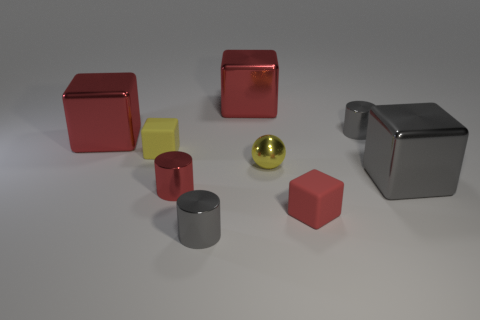Subtract all red cubes. How many were subtracted if there are1red cubes left? 2 Subtract all gray cylinders. How many red cubes are left? 3 Subtract 1 cubes. How many cubes are left? 4 Subtract all yellow blocks. How many blocks are left? 4 Subtract all tiny yellow cubes. How many cubes are left? 4 Subtract all blue cubes. Subtract all purple cylinders. How many cubes are left? 5 Add 1 gray metal blocks. How many objects exist? 10 Subtract all cubes. How many objects are left? 4 Add 6 red blocks. How many red blocks are left? 9 Add 7 small red cubes. How many small red cubes exist? 8 